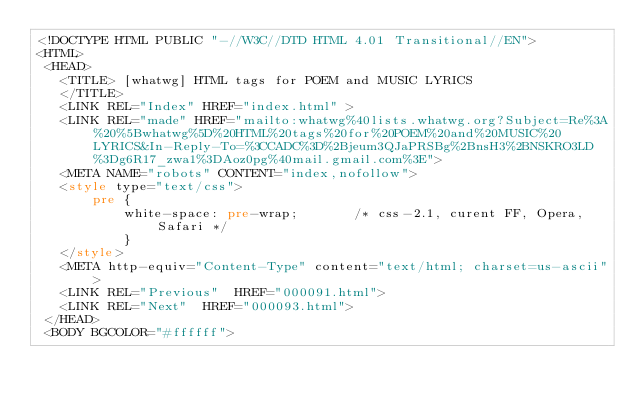<code> <loc_0><loc_0><loc_500><loc_500><_HTML_><!DOCTYPE HTML PUBLIC "-//W3C//DTD HTML 4.01 Transitional//EN">
<HTML>
 <HEAD>
   <TITLE> [whatwg] HTML tags for POEM and MUSIC LYRICS
   </TITLE>
   <LINK REL="Index" HREF="index.html" >
   <LINK REL="made" HREF="mailto:whatwg%40lists.whatwg.org?Subject=Re%3A%20%5Bwhatwg%5D%20HTML%20tags%20for%20POEM%20and%20MUSIC%20LYRICS&In-Reply-To=%3CCADC%3D%2Bjeum3QJaPRSBg%2BnsH3%2BNSKRO3LD%3Dg6R17_zwa1%3DAoz0pg%40mail.gmail.com%3E">
   <META NAME="robots" CONTENT="index,nofollow">
   <style type="text/css">
       pre {
           white-space: pre-wrap;       /* css-2.1, curent FF, Opera, Safari */
           }
   </style>
   <META http-equiv="Content-Type" content="text/html; charset=us-ascii">
   <LINK REL="Previous"  HREF="000091.html">
   <LINK REL="Next"  HREF="000093.html">
 </HEAD>
 <BODY BGCOLOR="#ffffff"></code> 